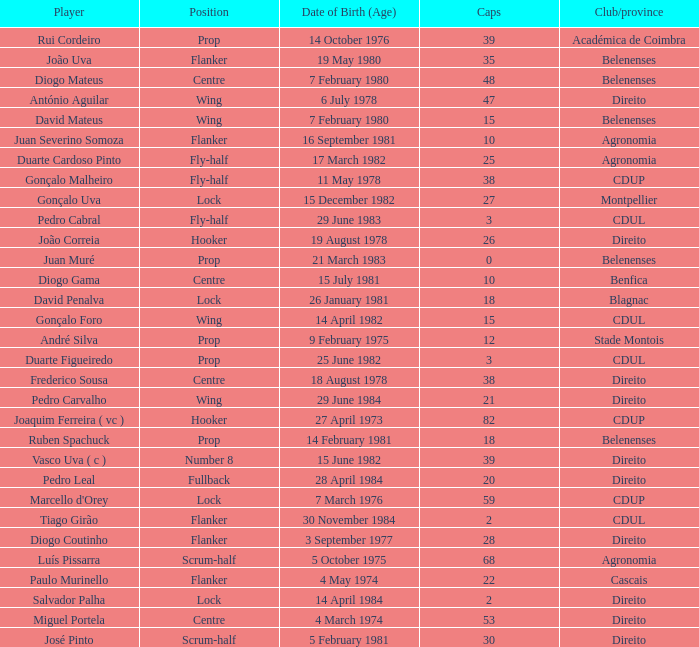Which player has a Position of fly-half, and a Caps of 3? Pedro Cabral. 